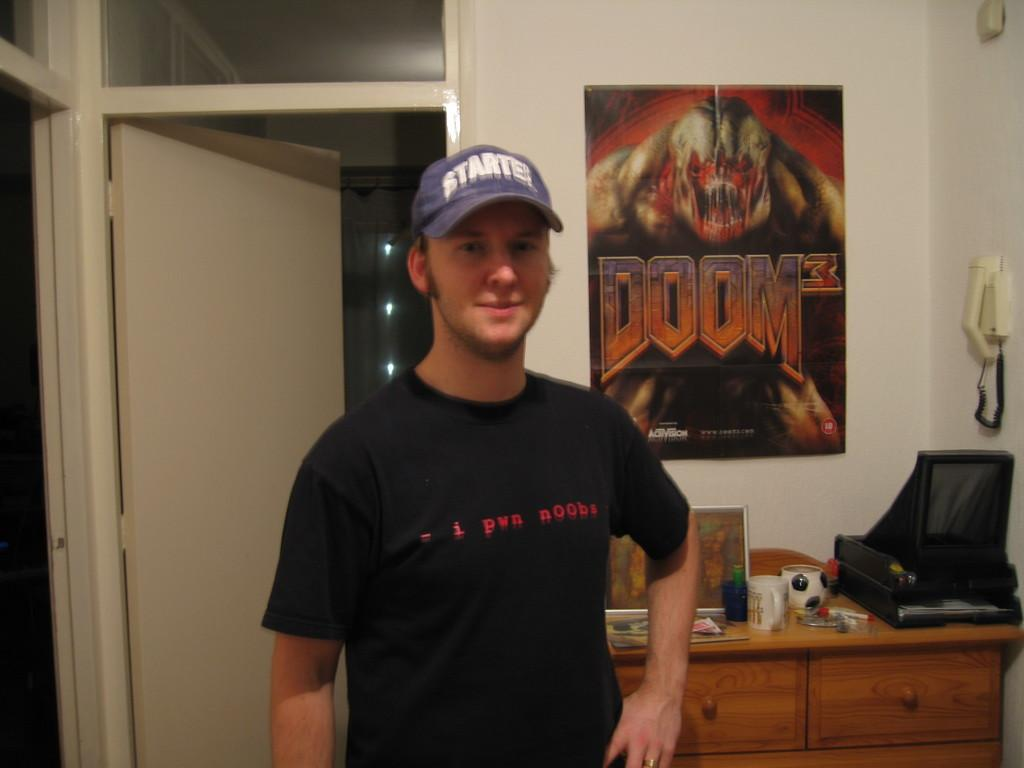Provide a one-sentence caption for the provided image. A man in a black shirt is is wearing a Starter hat. 